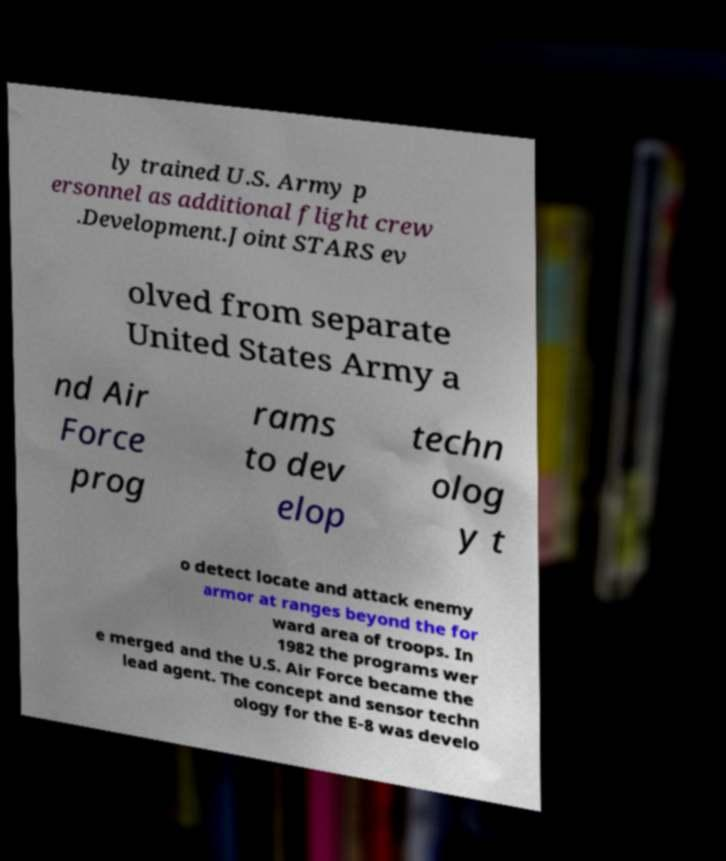Can you read and provide the text displayed in the image?This photo seems to have some interesting text. Can you extract and type it out for me? ly trained U.S. Army p ersonnel as additional flight crew .Development.Joint STARS ev olved from separate United States Army a nd Air Force prog rams to dev elop techn olog y t o detect locate and attack enemy armor at ranges beyond the for ward area of troops. In 1982 the programs wer e merged and the U.S. Air Force became the lead agent. The concept and sensor techn ology for the E-8 was develo 